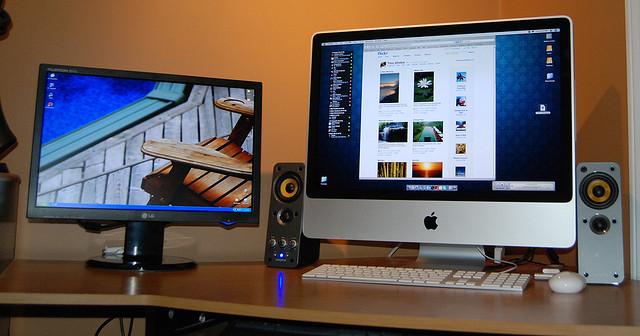What is on the screen with the apple logo?
Concise answer only. Pictures. What color is the mouse?
Answer briefly. White. What brand of computer is this?
Keep it brief. Apple. What device is orange in the picture?
Concise answer only. Speaker. Are there speakers in the picture?
Quick response, please. Yes. 